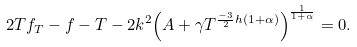<formula> <loc_0><loc_0><loc_500><loc_500>2 T f _ { T } - f - T - 2 k ^ { 2 } { \left ( { A + \gamma T ^ { \frac { - 3 } { 2 } h ( 1 + \alpha ) } } \right ) } ^ { \frac { 1 } { 1 + \alpha } } = 0 .</formula> 